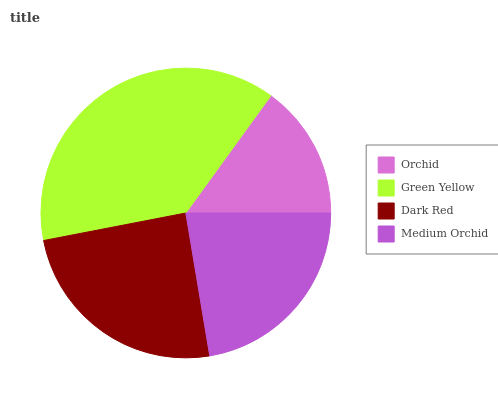Is Orchid the minimum?
Answer yes or no. Yes. Is Green Yellow the maximum?
Answer yes or no. Yes. Is Dark Red the minimum?
Answer yes or no. No. Is Dark Red the maximum?
Answer yes or no. No. Is Green Yellow greater than Dark Red?
Answer yes or no. Yes. Is Dark Red less than Green Yellow?
Answer yes or no. Yes. Is Dark Red greater than Green Yellow?
Answer yes or no. No. Is Green Yellow less than Dark Red?
Answer yes or no. No. Is Dark Red the high median?
Answer yes or no. Yes. Is Medium Orchid the low median?
Answer yes or no. Yes. Is Orchid the high median?
Answer yes or no. No. Is Orchid the low median?
Answer yes or no. No. 